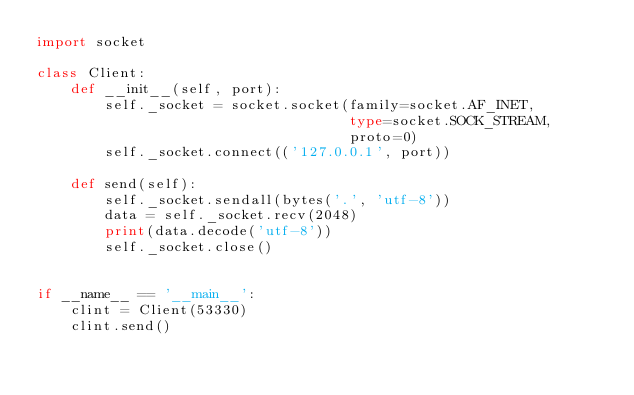<code> <loc_0><loc_0><loc_500><loc_500><_Python_>import socket

class Client:
    def __init__(self, port):
        self._socket = socket.socket(family=socket.AF_INET,
                                     type=socket.SOCK_STREAM,
                                     proto=0)
        self._socket.connect(('127.0.0.1', port))

    def send(self):
        self._socket.sendall(bytes('.', 'utf-8'))
        data = self._socket.recv(2048)
        print(data.decode('utf-8'))
        self._socket.close()


if __name__ == '__main__':
    clint = Client(53330)
    clint.send()</code> 